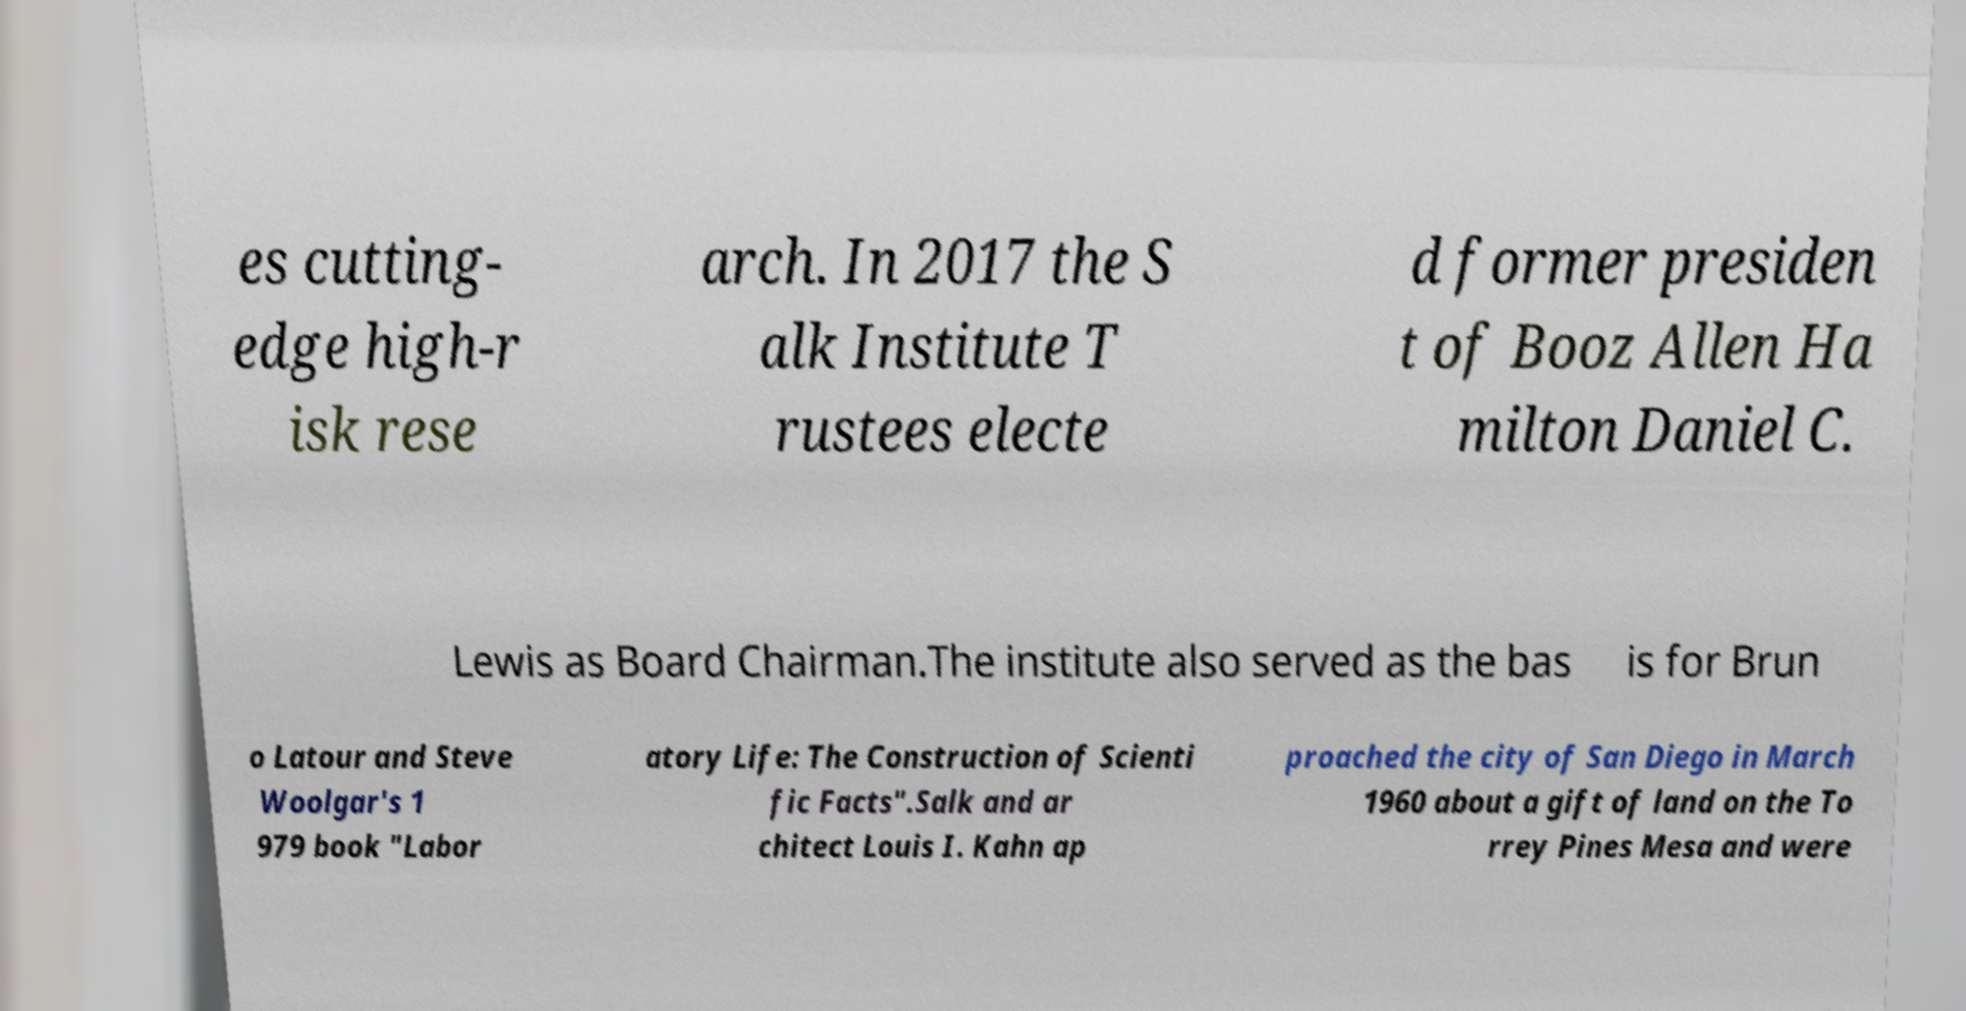Could you assist in decoding the text presented in this image and type it out clearly? es cutting- edge high-r isk rese arch. In 2017 the S alk Institute T rustees electe d former presiden t of Booz Allen Ha milton Daniel C. Lewis as Board Chairman.The institute also served as the bas is for Brun o Latour and Steve Woolgar's 1 979 book "Labor atory Life: The Construction of Scienti fic Facts".Salk and ar chitect Louis I. Kahn ap proached the city of San Diego in March 1960 about a gift of land on the To rrey Pines Mesa and were 